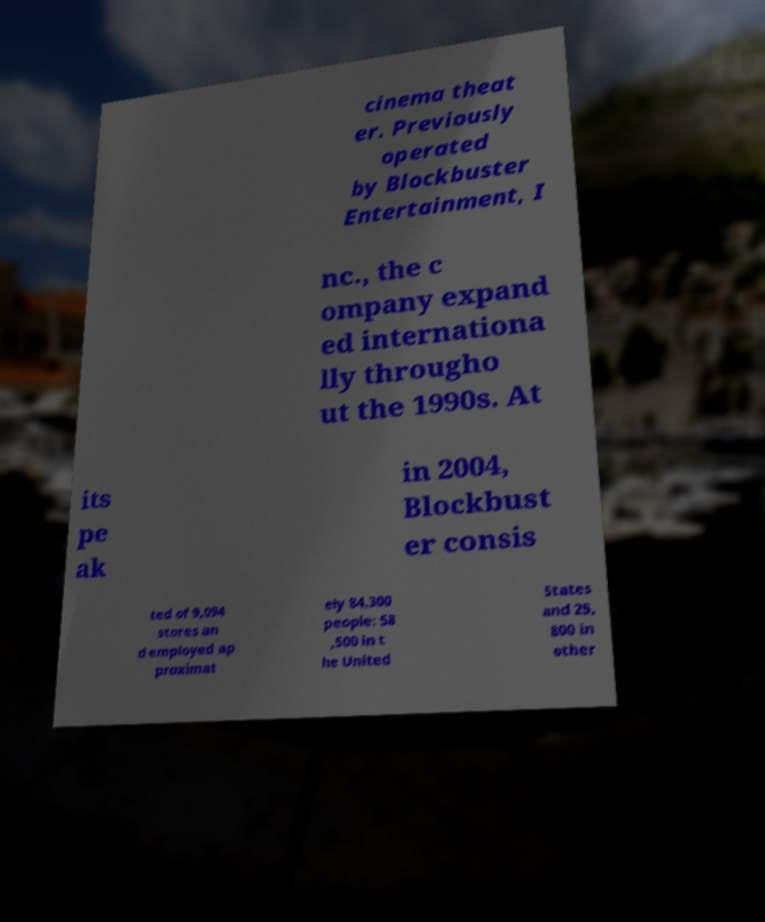There's text embedded in this image that I need extracted. Can you transcribe it verbatim? cinema theat er. Previously operated by Blockbuster Entertainment, I nc., the c ompany expand ed internationa lly througho ut the 1990s. At its pe ak in 2004, Blockbust er consis ted of 9,094 stores an d employed ap proximat ely 84,300 people: 58 ,500 in t he United States and 25, 800 in other 